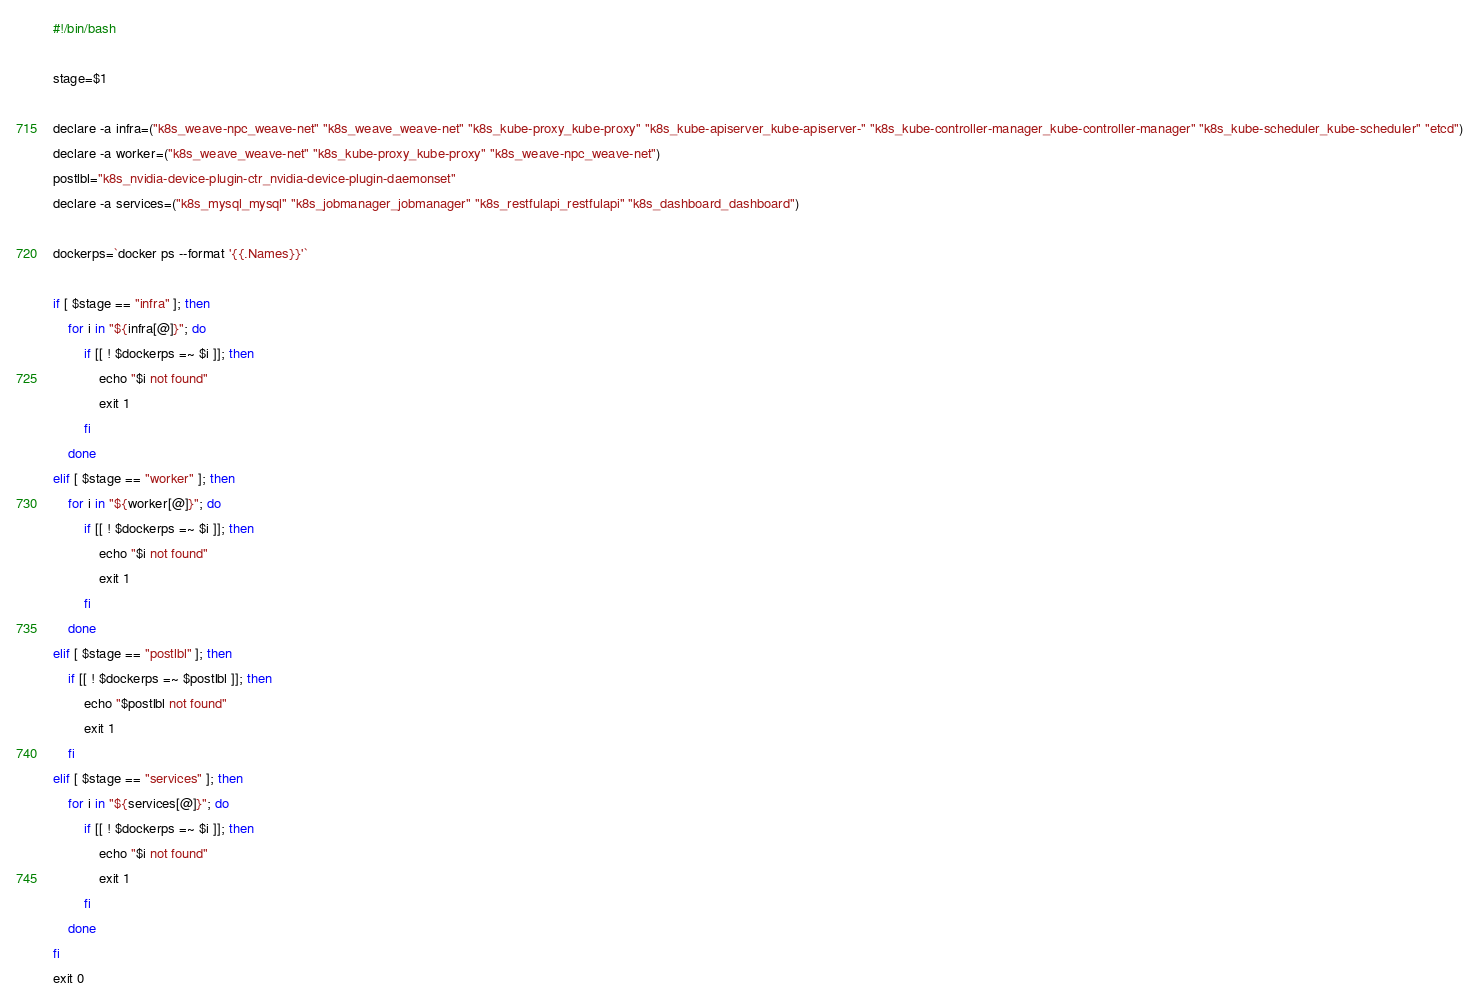<code> <loc_0><loc_0><loc_500><loc_500><_Bash_>#!/bin/bash

stage=$1

declare -a infra=("k8s_weave-npc_weave-net" "k8s_weave_weave-net" "k8s_kube-proxy_kube-proxy" "k8s_kube-apiserver_kube-apiserver-" "k8s_kube-controller-manager_kube-controller-manager" "k8s_kube-scheduler_kube-scheduler" "etcd")
declare -a worker=("k8s_weave_weave-net" "k8s_kube-proxy_kube-proxy" "k8s_weave-npc_weave-net")
postlbl="k8s_nvidia-device-plugin-ctr_nvidia-device-plugin-daemonset"
declare -a services=("k8s_mysql_mysql" "k8s_jobmanager_jobmanager" "k8s_restfulapi_restfulapi" "k8s_dashboard_dashboard")

dockerps=`docker ps --format '{{.Names}}'`

if [ $stage == "infra" ]; then
	for i in "${infra[@]}"; do
		if [[ ! $dockerps =~ $i ]]; then
			echo "$i not found"
			exit 1
		fi
	done
elif [ $stage == "worker" ]; then
	for i in "${worker[@]}"; do
		if [[ ! $dockerps =~ $i ]]; then
			echo "$i not found"
			exit 1
		fi
	done
elif [ $stage == "postlbl" ]; then
	if [[ ! $dockerps =~ $postlbl ]]; then
		echo "$postlbl not found"
		exit 1
	fi
elif [ $stage == "services" ]; then
	for i in "${services[@]}"; do
		if [[ ! $dockerps =~ $i ]]; then
			echo "$i not found"
			exit 1
		fi
	done
fi
exit 0</code> 